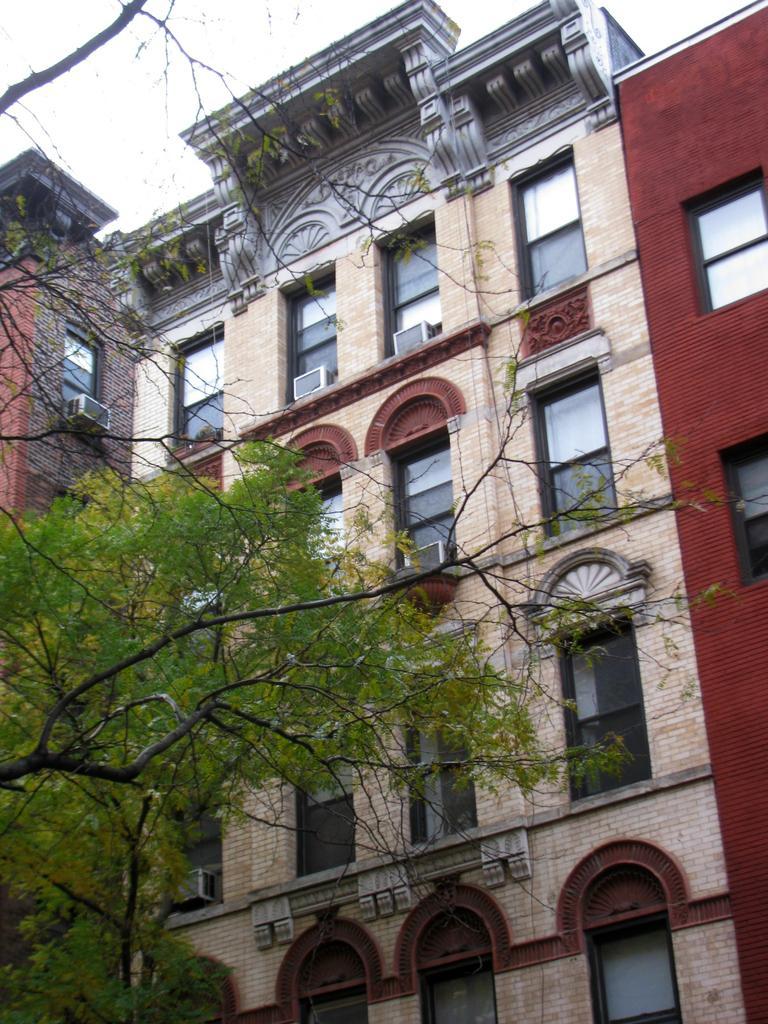Could you give a brief overview of what you see in this image? There is a building and there is a tree in front of it. 